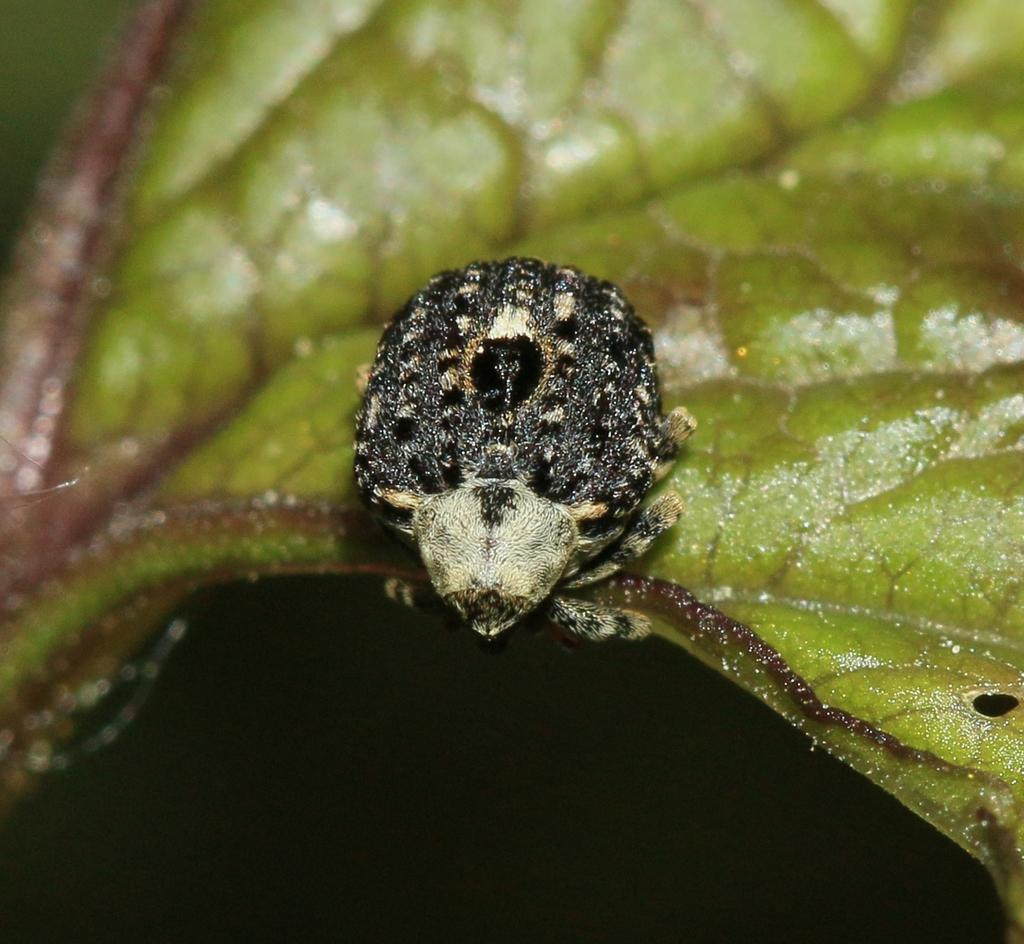What is present on the leaf in the image? There is an insect on the leaf in the image. Can you describe the insect's location on the leaf? The insect is on the leaf in the image. What type of flower is the insect pollinating in the image? There is no flower present in the image; the insect is on a leaf. How does the insect adjust its position on the leaf during the baseball game? There is no baseball game present in the image, and the insect is not adjusting its position on the leaf. 